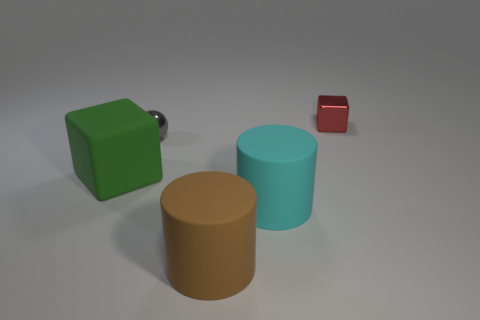Is there a small cyan ball made of the same material as the green object?
Ensure brevity in your answer.  No. What color is the shiny block?
Your response must be concise. Red. What size is the rubber cylinder that is behind the brown cylinder?
Provide a short and direct response. Large. How many other blocks have the same color as the tiny shiny block?
Make the answer very short. 0. There is a block that is behind the green rubber thing; is there a big green matte object to the right of it?
Provide a succinct answer. No. Do the cube right of the green matte object and the rubber object left of the gray metallic ball have the same color?
Your answer should be very brief. No. There is another thing that is the same size as the red thing; what color is it?
Your answer should be very brief. Gray. Is the number of metal spheres in front of the brown rubber object the same as the number of small metal spheres left of the big green matte block?
Provide a succinct answer. Yes. The big object in front of the cylinder behind the brown matte object is made of what material?
Offer a very short reply. Rubber. What number of objects are large blue matte things or tiny cubes?
Give a very brief answer. 1. 